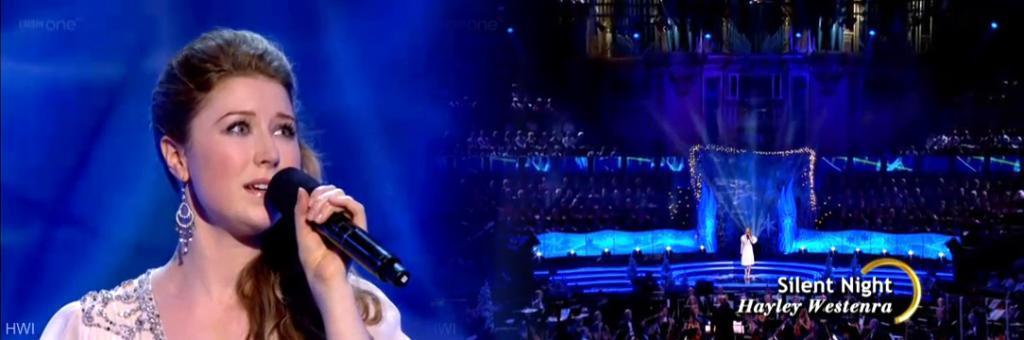In one or two sentences, can you explain what this image depicts? In this image I can see the woman is holding a microphone. On the right side, I can see people and the woman is standing on the stage. I can also see stage lights. Here I can see a watermark. 